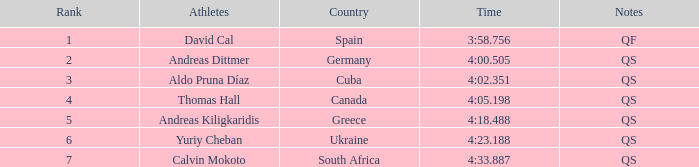What is Calvin Mokoto's average rank? 7.0. 